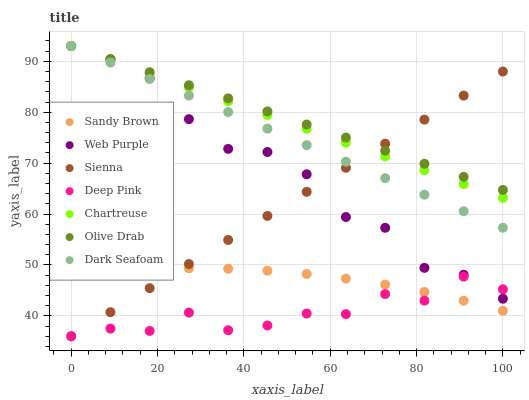Does Deep Pink have the minimum area under the curve?
Answer yes or no. Yes. Does Olive Drab have the maximum area under the curve?
Answer yes or no. Yes. Does Chartreuse have the minimum area under the curve?
Answer yes or no. No. Does Chartreuse have the maximum area under the curve?
Answer yes or no. No. Is Olive Drab the smoothest?
Answer yes or no. Yes. Is Deep Pink the roughest?
Answer yes or no. Yes. Is Chartreuse the smoothest?
Answer yes or no. No. Is Chartreuse the roughest?
Answer yes or no. No. Does Deep Pink have the lowest value?
Answer yes or no. Yes. Does Chartreuse have the lowest value?
Answer yes or no. No. Does Olive Drab have the highest value?
Answer yes or no. Yes. Does Sienna have the highest value?
Answer yes or no. No. Is Deep Pink less than Olive Drab?
Answer yes or no. Yes. Is Chartreuse greater than Deep Pink?
Answer yes or no. Yes. Does Chartreuse intersect Dark Seafoam?
Answer yes or no. Yes. Is Chartreuse less than Dark Seafoam?
Answer yes or no. No. Is Chartreuse greater than Dark Seafoam?
Answer yes or no. No. Does Deep Pink intersect Olive Drab?
Answer yes or no. No. 